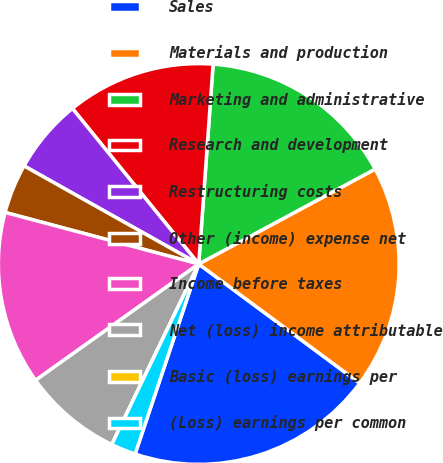<chart> <loc_0><loc_0><loc_500><loc_500><pie_chart><fcel>Sales<fcel>Materials and production<fcel>Marketing and administrative<fcel>Research and development<fcel>Restructuring costs<fcel>Other (income) expense net<fcel>Income before taxes<fcel>Net (loss) income attributable<fcel>Basic (loss) earnings per<fcel>(Loss) earnings per common<nl><fcel>20.0%<fcel>18.0%<fcel>16.0%<fcel>12.0%<fcel>6.0%<fcel>4.0%<fcel>14.0%<fcel>8.0%<fcel>0.0%<fcel>2.0%<nl></chart> 